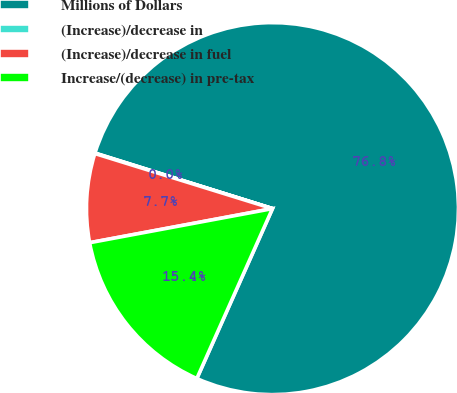Convert chart to OTSL. <chart><loc_0><loc_0><loc_500><loc_500><pie_chart><fcel>Millions of Dollars<fcel>(Increase)/decrease in<fcel>(Increase)/decrease in fuel<fcel>Increase/(decrease) in pre-tax<nl><fcel>76.84%<fcel>0.04%<fcel>7.72%<fcel>15.4%<nl></chart> 